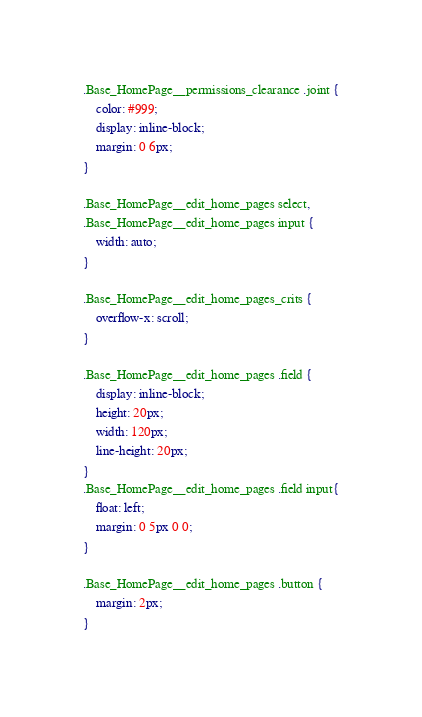<code> <loc_0><loc_0><loc_500><loc_500><_CSS_>.Base_HomePage__permissions_clearance .joint {
	color: #999;
	display: inline-block;
	margin: 0 6px;
}

.Base_HomePage__edit_home_pages select,
.Base_HomePage__edit_home_pages input {
	width: auto;
}

.Base_HomePage__edit_home_pages_crits {
	overflow-x: scroll;
}

.Base_HomePage__edit_home_pages .field {
	display: inline-block;
	height: 20px;
	width: 120px;
	line-height: 20px;
}
.Base_HomePage__edit_home_pages .field input{
	float: left;
	margin: 0 5px 0 0;
}

.Base_HomePage__edit_home_pages .button {
	margin: 2px;
}</code> 